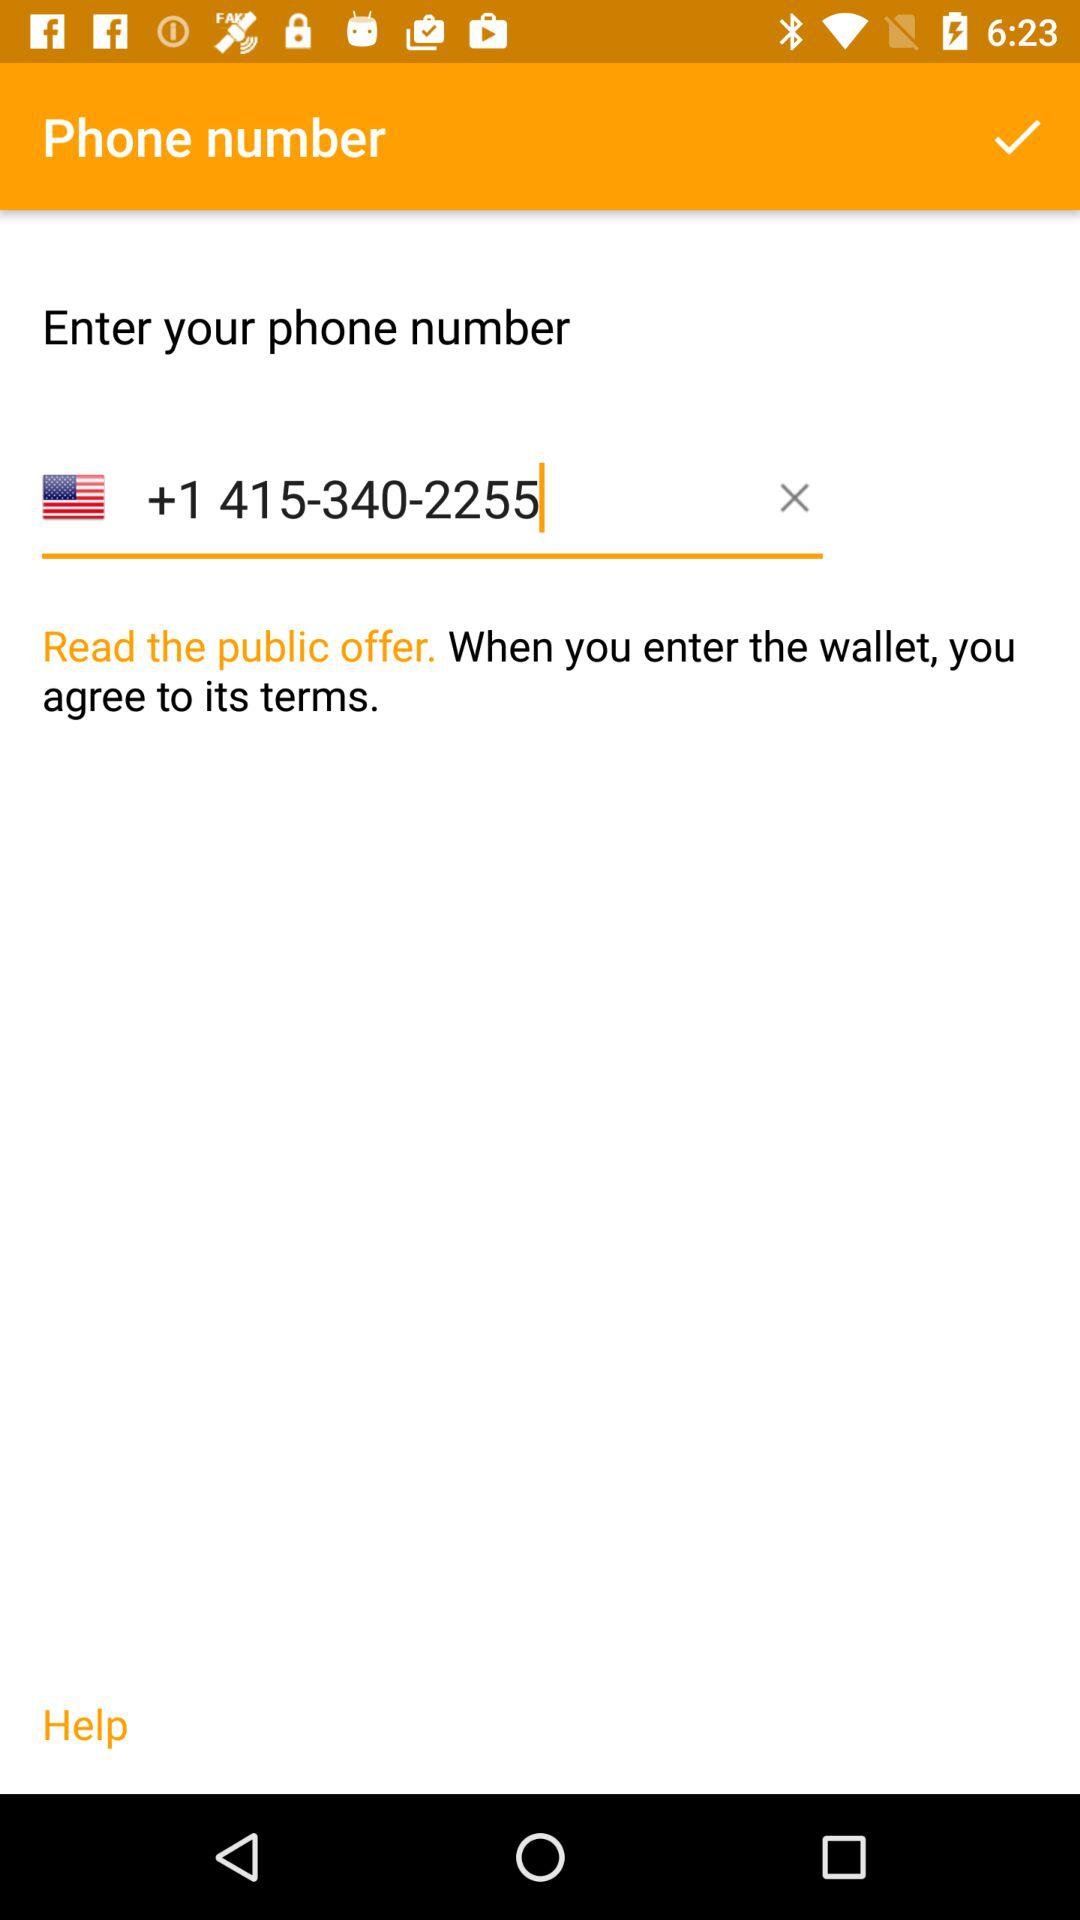What is the phone number? The phone number is +1 415-340-2255. 